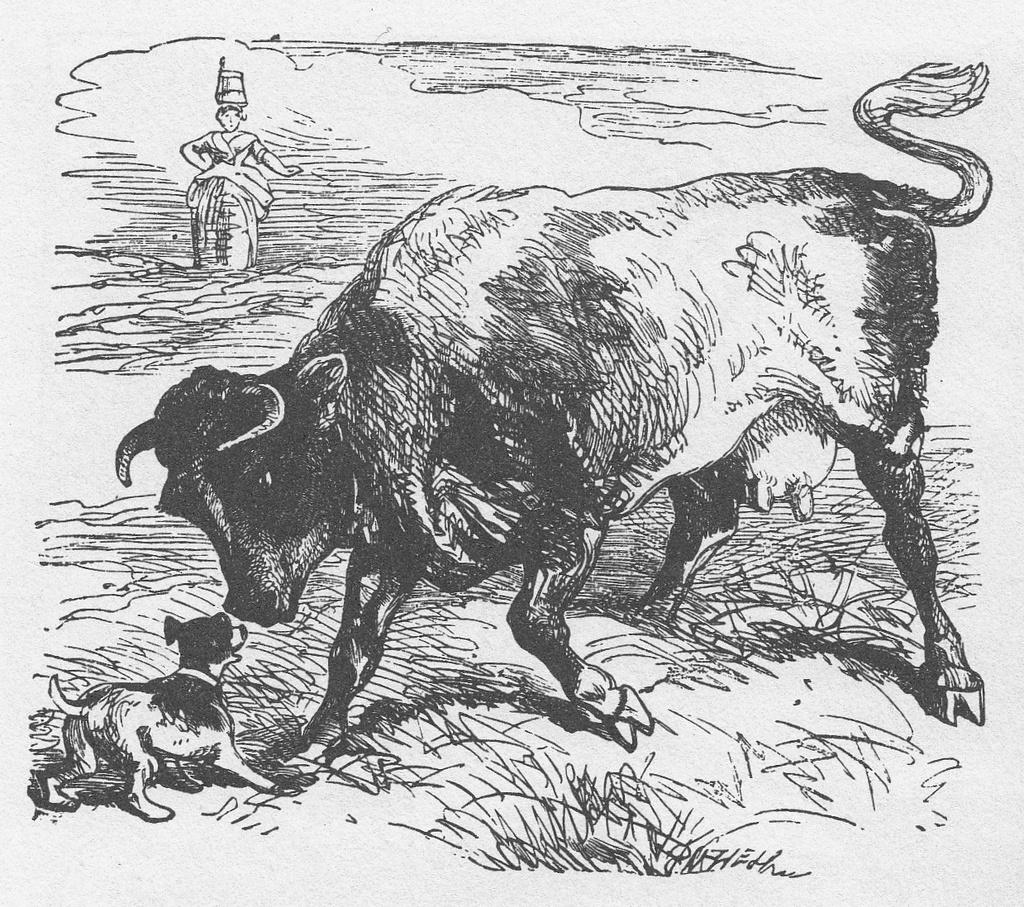What is the main subject of the image? The main subject of the image is an art of a bull. What is the bull doing in the image? The bull is standing in front of a dog. What is the setting of the image? The scene takes place on grassland. Is there anyone else present in the image? Yes, there is a woman standing on the left side of the image. What type of chalk is the woman using to draw on the grass? There is no chalk present in the image, and the woman is not drawing on the grass. 